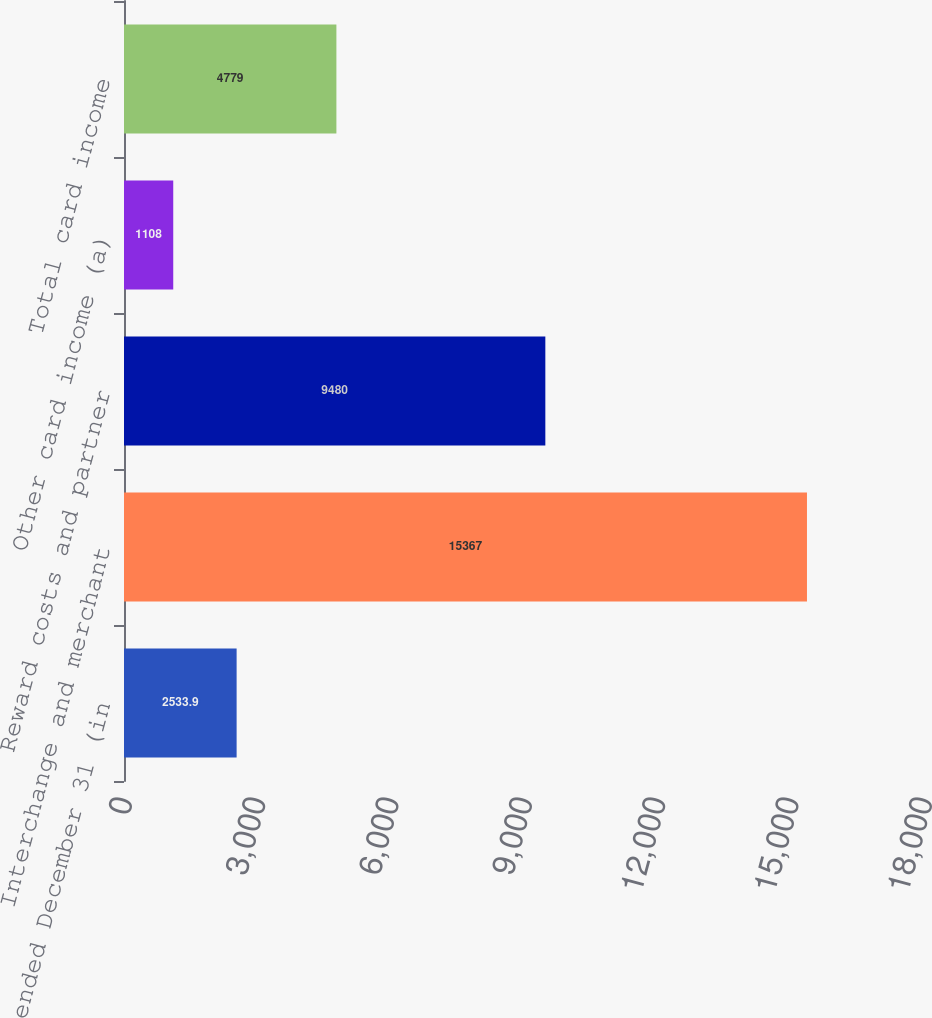Convert chart. <chart><loc_0><loc_0><loc_500><loc_500><bar_chart><fcel>Year ended December 31 (in<fcel>Interchange and merchant<fcel>Reward costs and partner<fcel>Other card income (a)<fcel>Total card income<nl><fcel>2533.9<fcel>15367<fcel>9480<fcel>1108<fcel>4779<nl></chart> 